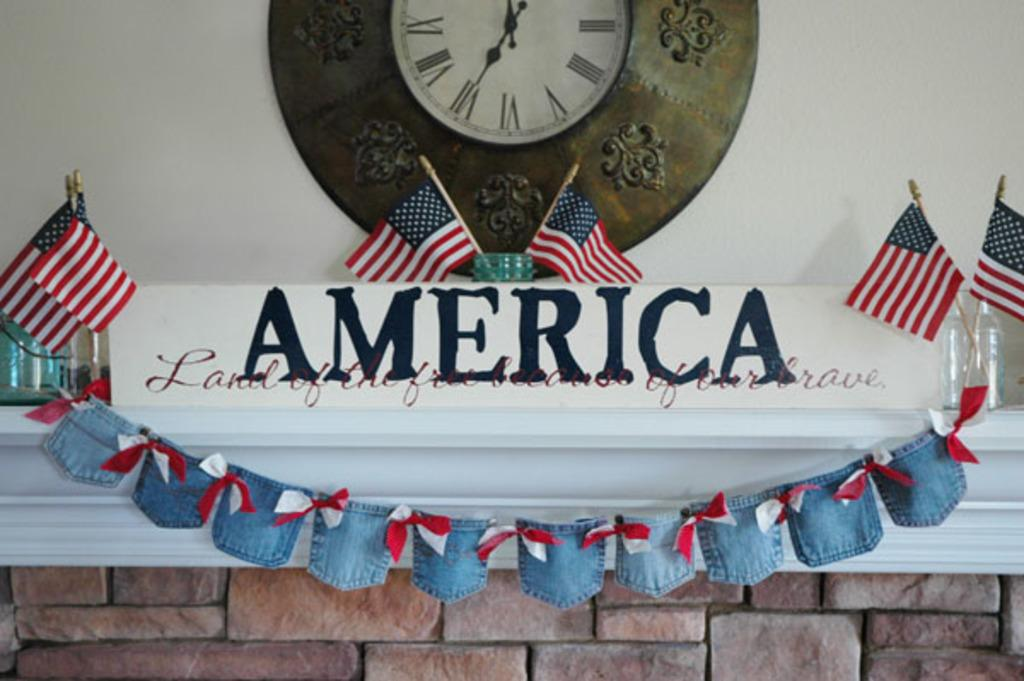<image>
Share a concise interpretation of the image provided. A fireplace mantle that says America on it surrounded by flags. 